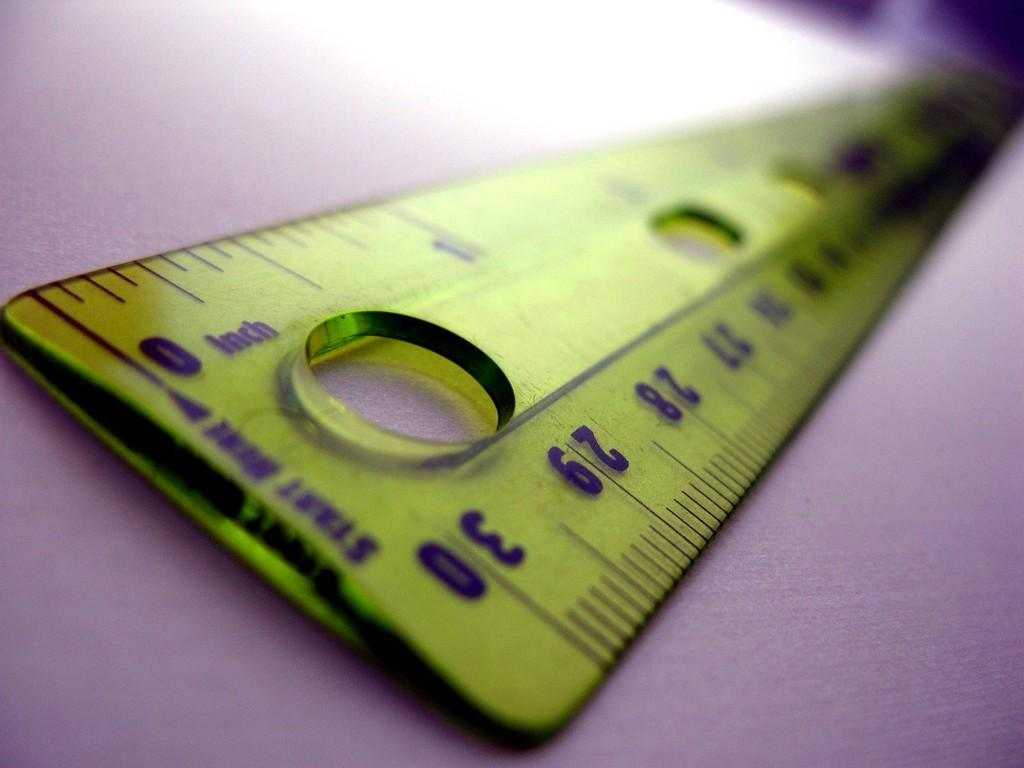<image>
Create a compact narrative representing the image presented. A ruler has an arrow pointing to the zero with a note that says "start here". 